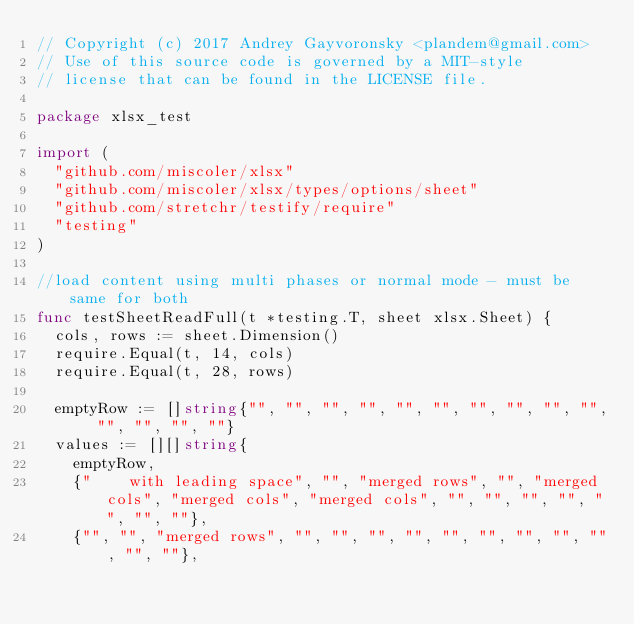<code> <loc_0><loc_0><loc_500><loc_500><_Go_>// Copyright (c) 2017 Andrey Gayvoronsky <plandem@gmail.com>
// Use of this source code is governed by a MIT-style
// license that can be found in the LICENSE file.

package xlsx_test

import (
	"github.com/miscoler/xlsx"
	"github.com/miscoler/xlsx/types/options/sheet"
	"github.com/stretchr/testify/require"
	"testing"
)

//load content using multi phases or normal mode - must be same for both
func testSheetReadFull(t *testing.T, sheet xlsx.Sheet) {
	cols, rows := sheet.Dimension()
	require.Equal(t, 14, cols)
	require.Equal(t, 28, rows)

	emptyRow := []string{"", "", "", "", "", "", "", "", "", "", "", "", "", ""}
	values := [][]string{
		emptyRow,
		{"    with leading space", "", "merged rows", "", "merged cols", "merged cols", "merged cols", "", "", "", "", "", "", ""},
		{"", "", "merged rows", "", "", "", "", "", "", "", "", "", "", ""},</code> 